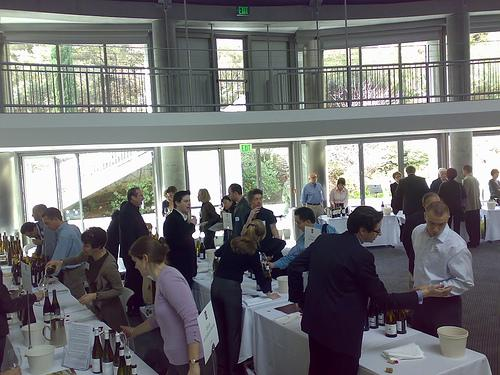What is on the table to the left?

Choices:
A) dog
B) chicken leg
C) wine bottles
D) cat wine bottles 